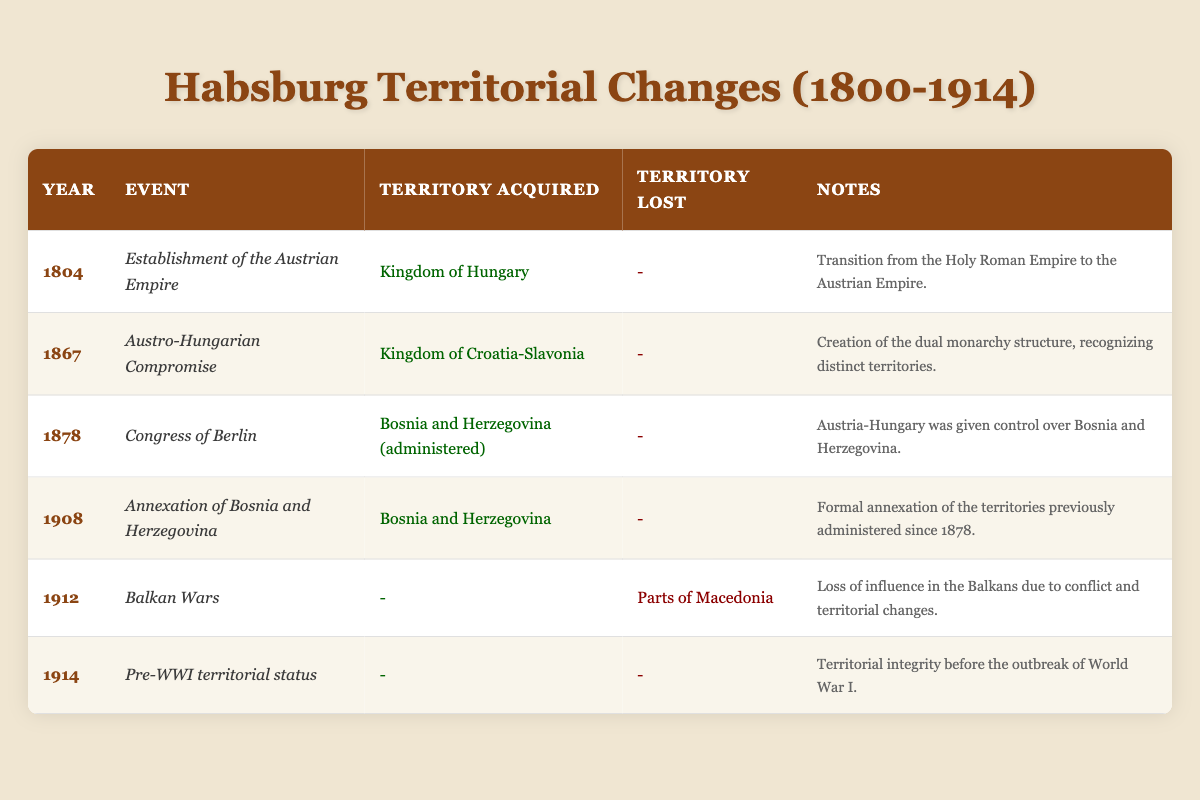What year was the Austrian Empire established? The table shows that the establishment of the Austrian Empire occurred in 1804.
Answer: 1804 Which territory was acquired in 1867? The entry for the year 1867 in the table indicates that the Kingdom of Croatia-Slavonia was acquired during the Austro-Hungarian Compromise.
Answer: Kingdom of Croatia-Slavonia Did the Habsburg dynasty lose any territory in 1912? According to the table, in 1912, the Habsburg dynasty lost parts of Macedonia due to the Balkan Wars.
Answer: Yes How many territories did the Habsburg dynasty acquire between 1804 and 1908? The table shows that there were three acquisitions: Kingdom of Hungary in 1804, Kingdom of Croatia-Slavonia in 1867, and Bosnia and Herzegovina in 1908 (previously administered since 1878). Thus, the total is three territories acquired.
Answer: Three territories What is the significance of the year 1914 in relation to the Habsburg dynasty's territories? The table states that 1914 marks the pre-WWI territorial status of the Habsburg dynasty, indicating that there was no change in territorial integrity before the outbreak of World War I.
Answer: No change in territorial integrity How many territories were formalized through annexation from 1878 to 1908? The table shows that Bosnia and Herzegovina was administered in 1878 and formally annexed in 1908. Thus, the only territory formalized by annexation in this period is Bosnia and Herzegovina.
Answer: One territory In how many events from the table was there a loss of territory and what were the territories? The table indicates one loss of territory in 1912, specifically parts of Macedonia due to the Balkan Wars. Thus, there is one event where territory was lost, which is in the year 1912.
Answer: One event, parts of Macedonia Was there any territory lost during the establishment of the Austrian Empire in 1804? The table does not list any territories lost in the year 1804 when the Austrian Empire was established; instead, it states the acquisition of the Kingdom of Hungary.
Answer: No Which event led to the acquisition of Bosnia and Herzegovina, and in what year did this occur? The table indicates that Bosnia and Herzegovina were acquired through the Congress of Berlin in 1878, which allowed Austria-Hungary to control the area.
Answer: Congress of Berlin in 1878 